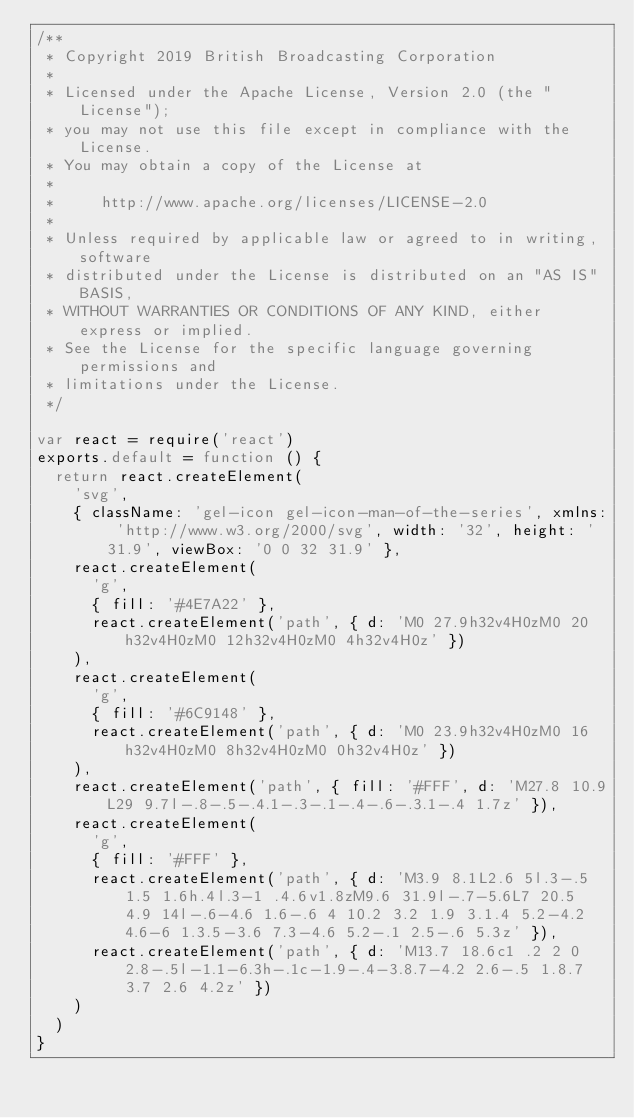<code> <loc_0><loc_0><loc_500><loc_500><_JavaScript_>/**
 * Copyright 2019 British Broadcasting Corporation
 *
 * Licensed under the Apache License, Version 2.0 (the "License");
 * you may not use this file except in compliance with the License.
 * You may obtain a copy of the License at
 *
 *     http://www.apache.org/licenses/LICENSE-2.0
 *
 * Unless required by applicable law or agreed to in writing, software
 * distributed under the License is distributed on an "AS IS" BASIS,
 * WITHOUT WARRANTIES OR CONDITIONS OF ANY KIND, either express or implied.
 * See the License for the specific language governing permissions and
 * limitations under the License.
 */

var react = require('react')
exports.default = function () {
  return react.createElement(
    'svg',
    { className: 'gel-icon gel-icon-man-of-the-series', xmlns: 'http://www.w3.org/2000/svg', width: '32', height: '31.9', viewBox: '0 0 32 31.9' },
    react.createElement(
      'g',
      { fill: '#4E7A22' },
      react.createElement('path', { d: 'M0 27.9h32v4H0zM0 20h32v4H0zM0 12h32v4H0zM0 4h32v4H0z' })
    ),
    react.createElement(
      'g',
      { fill: '#6C9148' },
      react.createElement('path', { d: 'M0 23.9h32v4H0zM0 16h32v4H0zM0 8h32v4H0zM0 0h32v4H0z' })
    ),
    react.createElement('path', { fill: '#FFF', d: 'M27.8 10.9L29 9.7l-.8-.5-.4.1-.3-.1-.4-.6-.3.1-.4 1.7z' }),
    react.createElement(
      'g',
      { fill: '#FFF' },
      react.createElement('path', { d: 'M3.9 8.1L2.6 5l.3-.5 1.5 1.6h.4l.3-1 .4.6v1.8zM9.6 31.9l-.7-5.6L7 20.5 4.9 14l-.6-4.6 1.6-.6 4 10.2 3.2 1.9 3.1.4 5.2-4.2 4.6-6 1.3.5-3.6 7.3-4.6 5.2-.1 2.5-.6 5.3z' }),
      react.createElement('path', { d: 'M13.7 18.6c1 .2 2 0 2.8-.5l-1.1-6.3h-.1c-1.9-.4-3.8.7-4.2 2.6-.5 1.8.7 3.7 2.6 4.2z' })
    )
  )
}
</code> 